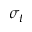<formula> <loc_0><loc_0><loc_500><loc_500>\sigma _ { t }</formula> 